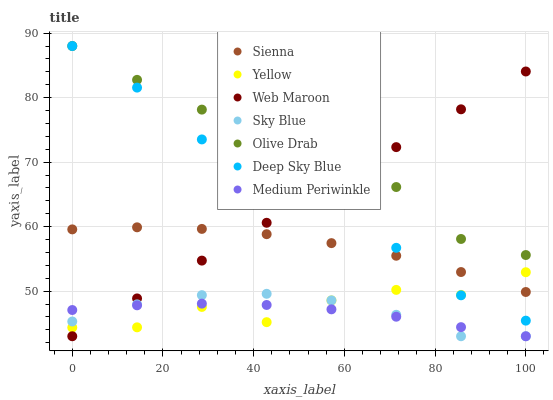Does Medium Periwinkle have the minimum area under the curve?
Answer yes or no. Yes. Does Olive Drab have the maximum area under the curve?
Answer yes or no. Yes. Does Web Maroon have the minimum area under the curve?
Answer yes or no. No. Does Web Maroon have the maximum area under the curve?
Answer yes or no. No. Is Web Maroon the smoothest?
Answer yes or no. Yes. Is Yellow the roughest?
Answer yes or no. Yes. Is Yellow the smoothest?
Answer yes or no. No. Is Web Maroon the roughest?
Answer yes or no. No. Does Medium Periwinkle have the lowest value?
Answer yes or no. Yes. Does Yellow have the lowest value?
Answer yes or no. No. Does Olive Drab have the highest value?
Answer yes or no. Yes. Does Web Maroon have the highest value?
Answer yes or no. No. Is Medium Periwinkle less than Sienna?
Answer yes or no. Yes. Is Deep Sky Blue greater than Medium Periwinkle?
Answer yes or no. Yes. Does Olive Drab intersect Deep Sky Blue?
Answer yes or no. Yes. Is Olive Drab less than Deep Sky Blue?
Answer yes or no. No. Is Olive Drab greater than Deep Sky Blue?
Answer yes or no. No. Does Medium Periwinkle intersect Sienna?
Answer yes or no. No. 